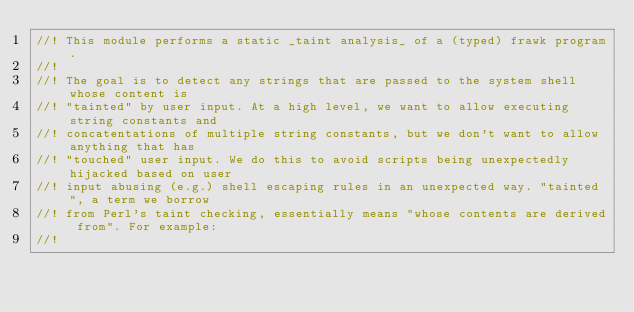Convert code to text. <code><loc_0><loc_0><loc_500><loc_500><_Rust_>//! This module performs a static _taint analysis_ of a (typed) frawk program.
//!
//! The goal is to detect any strings that are passed to the system shell whose content is
//! "tainted" by user input. At a high level, we want to allow executing string constants and
//! concatentations of multiple string constants, but we don't want to allow anything that has
//! "touched" user input. We do this to avoid scripts being unexpectedly hijacked based on user
//! input abusing (e.g.) shell escaping rules in an unexpected way. "tainted", a term we borrow
//! from Perl's taint checking, essentially means "whose contents are derived from". For example:
//!</code> 